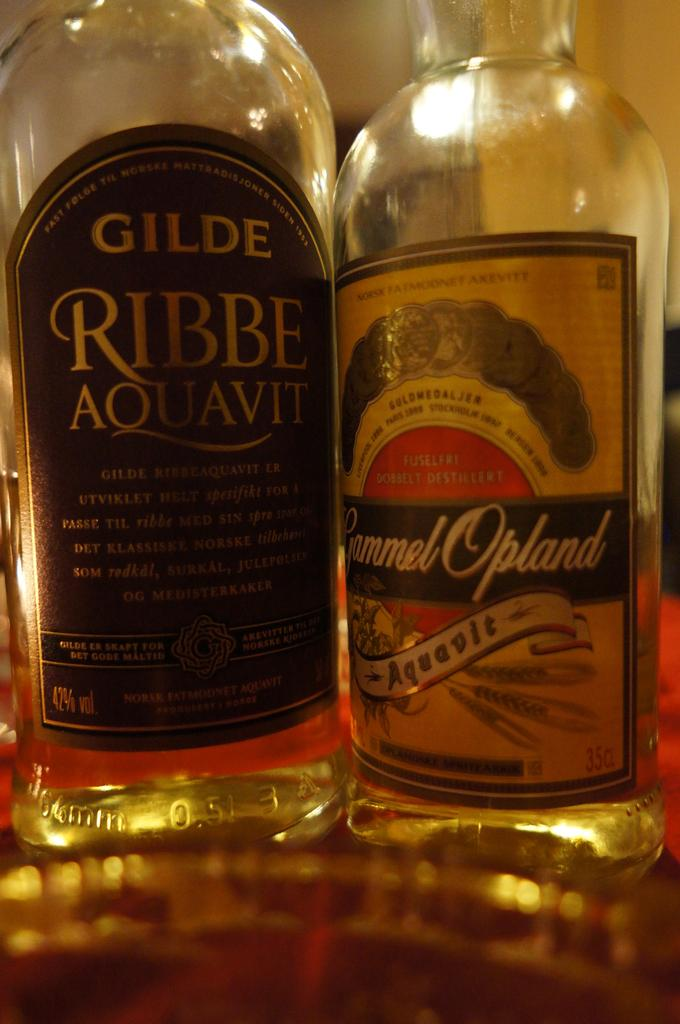<image>
Offer a succinct explanation of the picture presented. Ribbe Aquavit and Gyammel Opland type spirit drinks. 